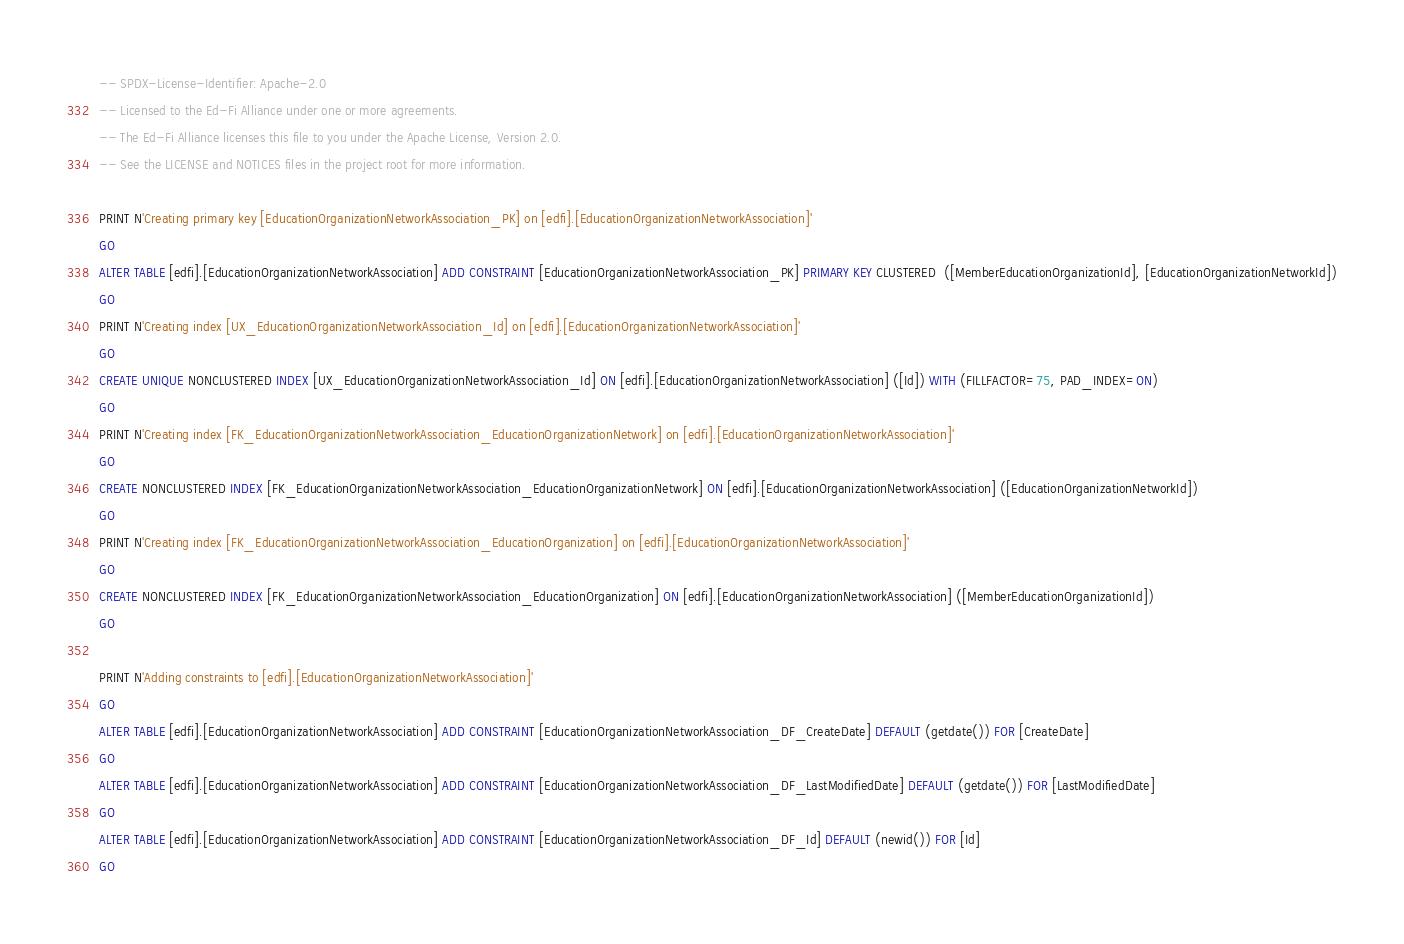<code> <loc_0><loc_0><loc_500><loc_500><_SQL_>-- SPDX-License-Identifier: Apache-2.0
-- Licensed to the Ed-Fi Alliance under one or more agreements.
-- The Ed-Fi Alliance licenses this file to you under the Apache License, Version 2.0.
-- See the LICENSE and NOTICES files in the project root for more information.

PRINT N'Creating primary key [EducationOrganizationNetworkAssociation_PK] on [edfi].[EducationOrganizationNetworkAssociation]'
GO
ALTER TABLE [edfi].[EducationOrganizationNetworkAssociation] ADD CONSTRAINT [EducationOrganizationNetworkAssociation_PK] PRIMARY KEY CLUSTERED  ([MemberEducationOrganizationId], [EducationOrganizationNetworkId])
GO
PRINT N'Creating index [UX_EducationOrganizationNetworkAssociation_Id] on [edfi].[EducationOrganizationNetworkAssociation]'
GO
CREATE UNIQUE NONCLUSTERED INDEX [UX_EducationOrganizationNetworkAssociation_Id] ON [edfi].[EducationOrganizationNetworkAssociation] ([Id]) WITH (FILLFACTOR=75, PAD_INDEX=ON)
GO
PRINT N'Creating index [FK_EducationOrganizationNetworkAssociation_EducationOrganizationNetwork] on [edfi].[EducationOrganizationNetworkAssociation]'
GO
CREATE NONCLUSTERED INDEX [FK_EducationOrganizationNetworkAssociation_EducationOrganizationNetwork] ON [edfi].[EducationOrganizationNetworkAssociation] ([EducationOrganizationNetworkId])
GO
PRINT N'Creating index [FK_EducationOrganizationNetworkAssociation_EducationOrganization] on [edfi].[EducationOrganizationNetworkAssociation]'
GO
CREATE NONCLUSTERED INDEX [FK_EducationOrganizationNetworkAssociation_EducationOrganization] ON [edfi].[EducationOrganizationNetworkAssociation] ([MemberEducationOrganizationId])
GO

PRINT N'Adding constraints to [edfi].[EducationOrganizationNetworkAssociation]'
GO
ALTER TABLE [edfi].[EducationOrganizationNetworkAssociation] ADD CONSTRAINT [EducationOrganizationNetworkAssociation_DF_CreateDate] DEFAULT (getdate()) FOR [CreateDate]
GO
ALTER TABLE [edfi].[EducationOrganizationNetworkAssociation] ADD CONSTRAINT [EducationOrganizationNetworkAssociation_DF_LastModifiedDate] DEFAULT (getdate()) FOR [LastModifiedDate]
GO
ALTER TABLE [edfi].[EducationOrganizationNetworkAssociation] ADD CONSTRAINT [EducationOrganizationNetworkAssociation_DF_Id] DEFAULT (newid()) FOR [Id]
GO

</code> 